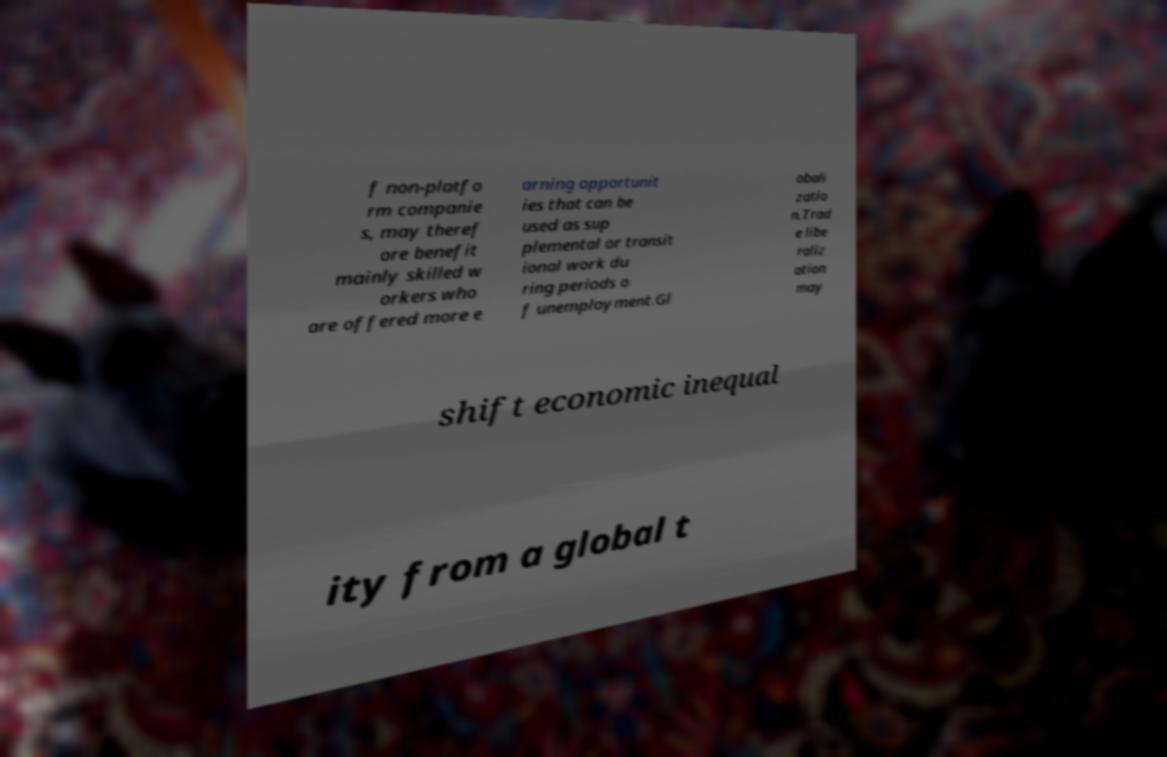Can you describe the image in terms of its composition and color palette? The image shows a piece of paper or card with text printed on it. The text is partially obscured and split across multiple lines. The paper has a slight shadow, suggesting it is not flat against a surface but instead propped at an angle. The background is blurred but appears to be a patterned fabric with a rich, multicolored design, predominantly red and blue. 